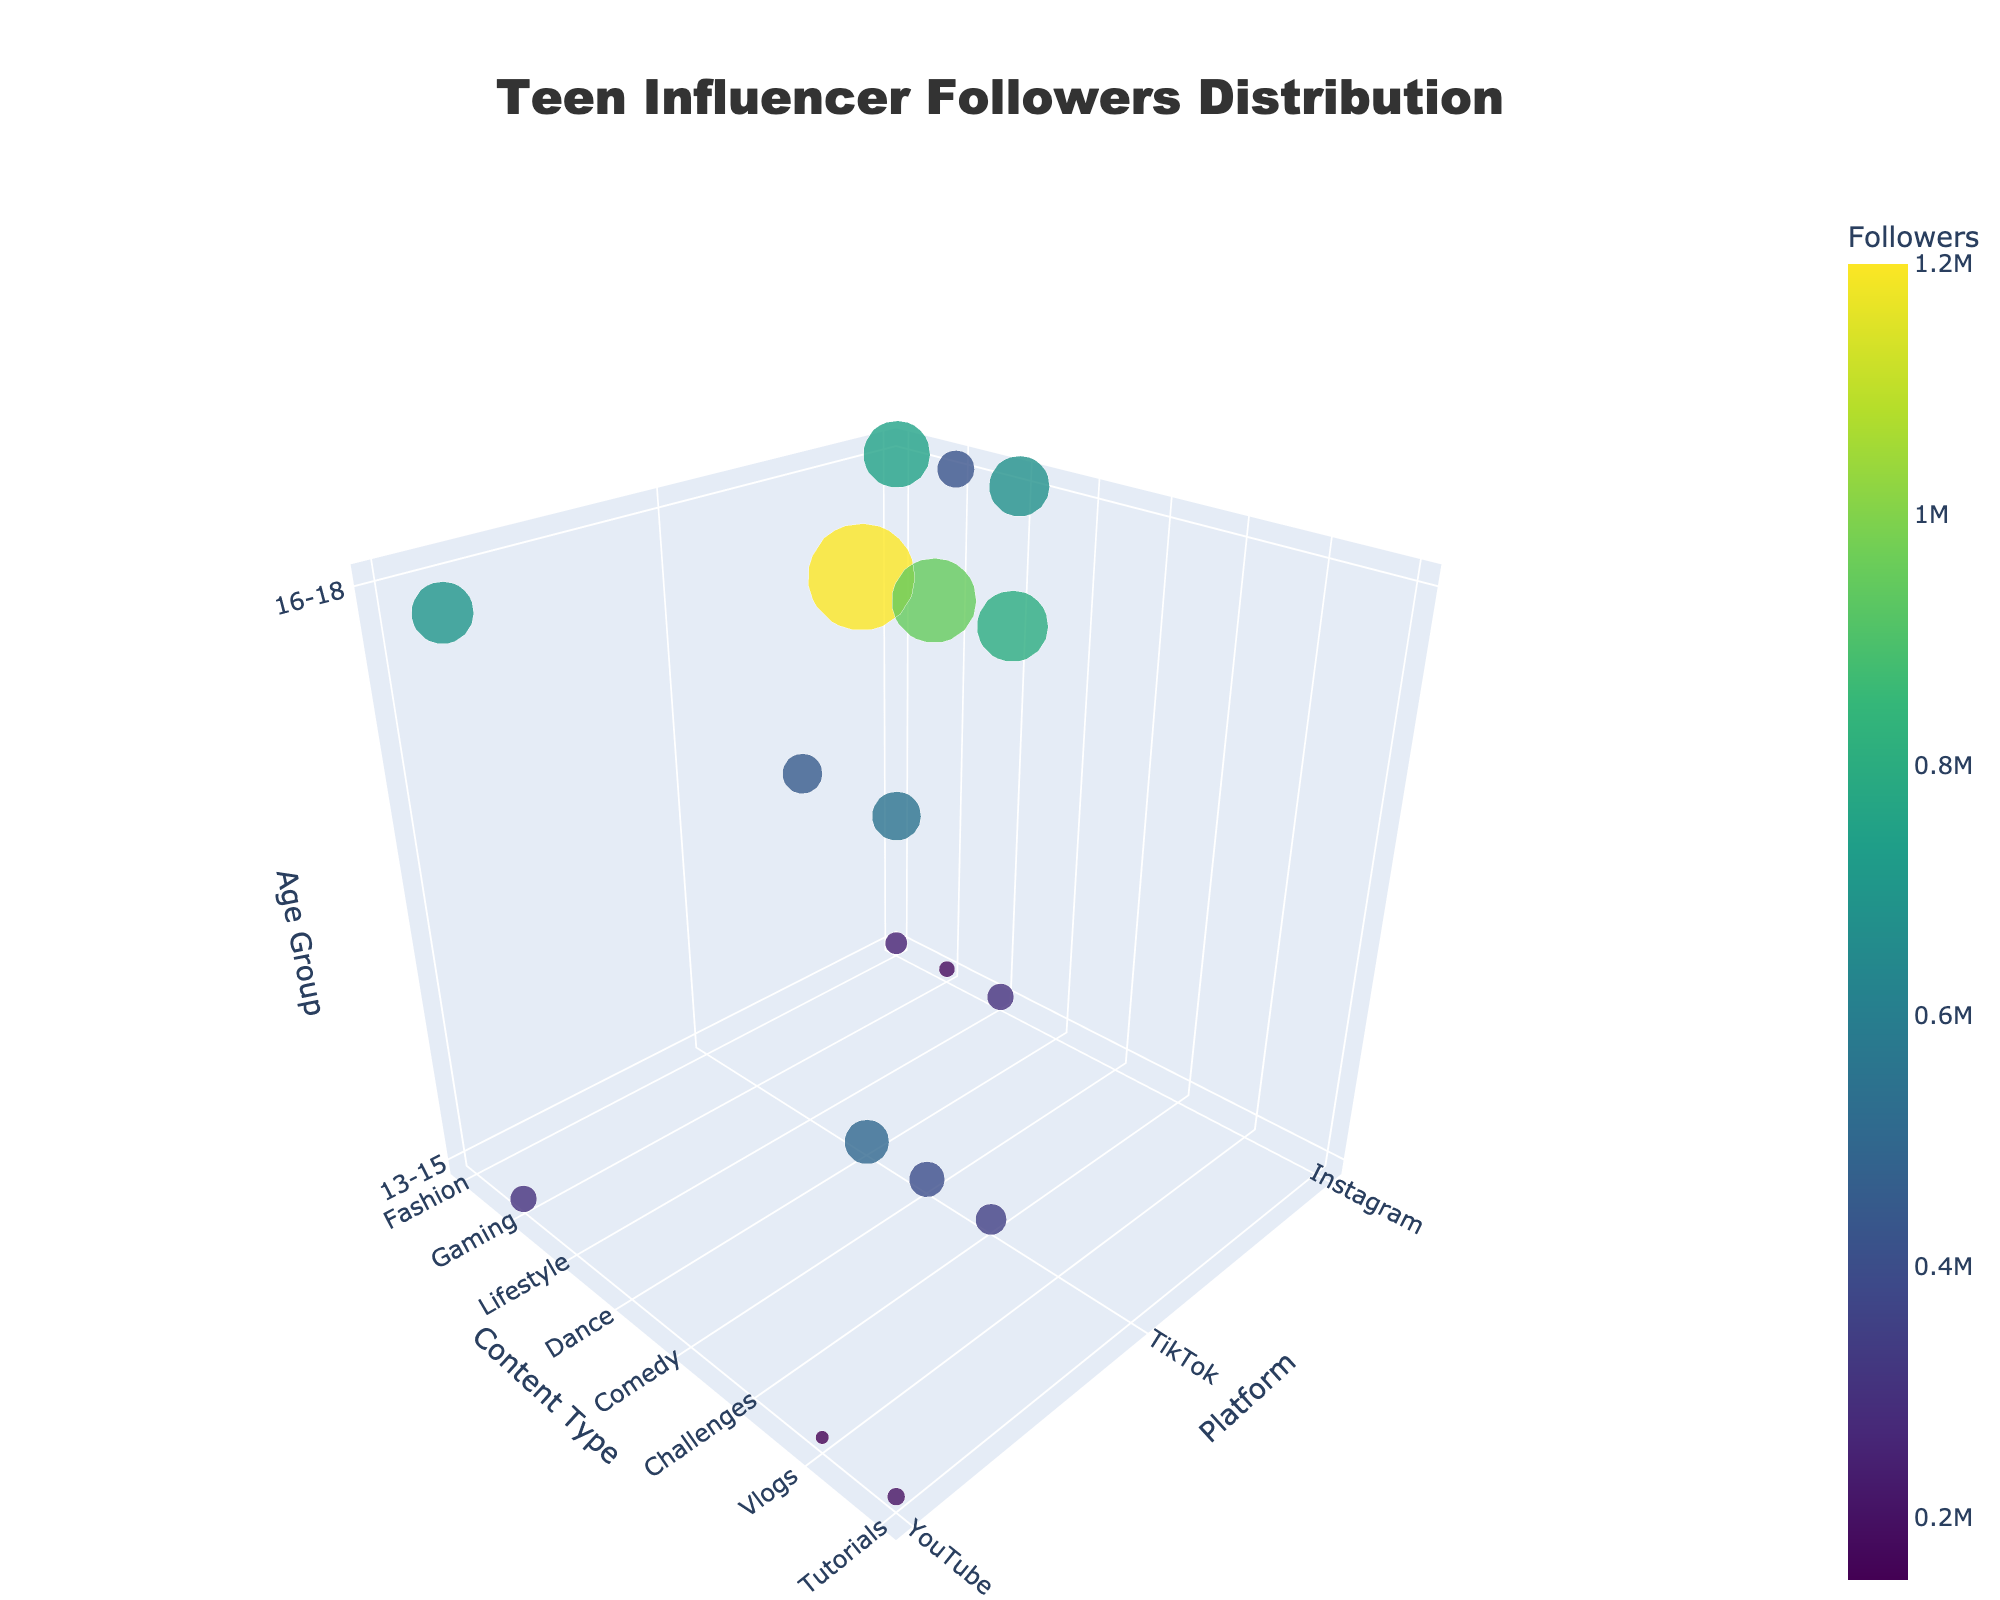What's the title of the figure? The title is typically positioned at the top of the figure. In this figure, the title text is 'Teen Influencer Followers Distribution'.
Answer: Teen Influencer Followers Distribution What are the axis titles? To identify the axis titles, you should look at the labels beside each axis in the 3D plot. The x-axis is labeled 'Platform', the y-axis is labeled 'Content Type', and the z-axis is labeled 'Age Group'.
Answer: Platform, Content Type, Age Group Which platform has the highest number of followers? By looking at the markers' sizes and colors in the figure, we can compare the platforms. TikTok has the largest markers, especially for the 'Dance' and 'Comedy' content types in the 16-18 age group.
Answer: TikTok How many different content types are represented in the figure? Each marker represents a different content type combined with a platform and an age group. Listing the unique content types shown: Fashion, Gaming, Lifestyle, Dance, Comedy, Challenges, Vlogs, Tutorials. Thus, there are 8 unique content types.
Answer: 8 Which content type on YouTube has the highest number of followers in the 16-18 age group? To determine this, focus on the markers under YouTube for the 16-18 age group. Comparing the marker sizes, 'Gaming' has the largest followers.
Answer: Gaming Compare the number of followers for Fashion content on Instagram between the age groups 13-15 and 16-18. Which age group has more followers and by how many? For the Instagram platform, Fashion content type has 250,000 followers for 13-15 and 750,000 for 16-18. The difference is 750,000 - 250,000 = 500,000.
Answer: 16-18, by 500,000 What is the total number of followers for TikTok in the 13-15 age group? Sum the followers for TikTok's 13-15 age group across all content types: Dance (500,000) + Comedy (400,000) + Challenges (350,000) = 1,250,000.
Answer: 1,250,000 Among Fashion, Gaming, and Lifestyle content types on Instagram, which has the lowest number of followers within the 13-15 age group? In the 13-15 age group on Instagram, Fashion has 250,000, Gaming has 180,000, and Lifestyle has 300,000 followers. The Gaming content type has the lowest number of followers.
Answer: Gaming Which age group has more followers on YouTube for Gaming content? Comparing the followers within the Gaming content type on YouTube, 13-15 age group has 300,000 and 16-18 has 700,000. The 16-18 age group has more followers.
Answer: 16-18 What is the average size of the followers for Comedy content type on TikTok across both age groups? Sum the number of followers for Comedy on TikTok for both age groups and then divide by 2. Comedy for 13-15 has 400,000 and for 16-18 has 950,000. The average is (400,000 + 950,000) / 2 = 675,000.
Answer: 675,000 